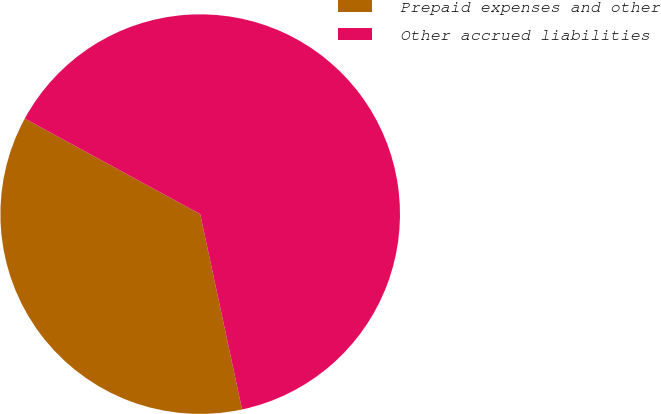<chart> <loc_0><loc_0><loc_500><loc_500><pie_chart><fcel>Prepaid expenses and other<fcel>Other accrued liabilities<nl><fcel>36.3%<fcel>63.7%<nl></chart> 